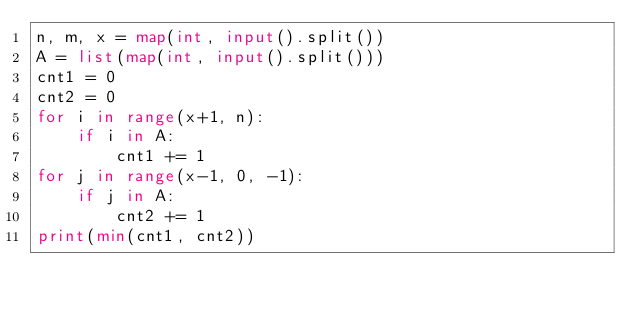<code> <loc_0><loc_0><loc_500><loc_500><_Python_>n, m, x = map(int, input().split())
A = list(map(int, input().split()))
cnt1 = 0
cnt2 = 0
for i in range(x+1, n):
    if i in A:
        cnt1 += 1
for j in range(x-1, 0, -1):
    if j in A:
        cnt2 += 1
print(min(cnt1, cnt2))
</code> 